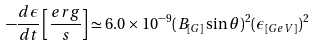<formula> <loc_0><loc_0><loc_500><loc_500>- \frac { d \epsilon } { d t } \left [ \frac { e r g } { s } \right ] \simeq 6 . 0 \times 1 0 ^ { - 9 } ( B _ { [ G ] } \sin \theta ) ^ { 2 } ( \epsilon _ { [ G e V ] } ) ^ { 2 }</formula> 